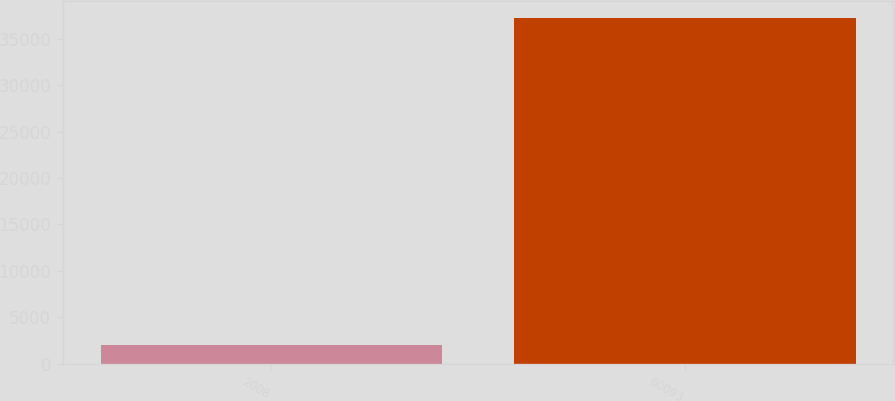<chart> <loc_0><loc_0><loc_500><loc_500><bar_chart><fcel>2008<fcel>60093<nl><fcel>2005<fcel>37166<nl></chart> 